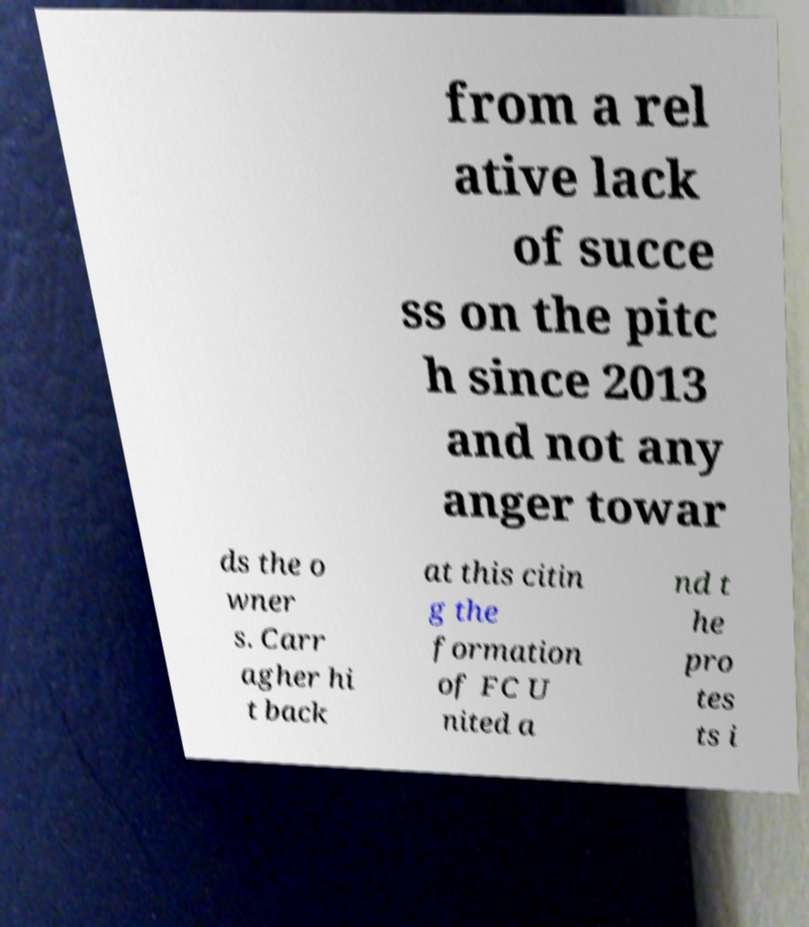What messages or text are displayed in this image? I need them in a readable, typed format. from a rel ative lack of succe ss on the pitc h since 2013 and not any anger towar ds the o wner s. Carr agher hi t back at this citin g the formation of FC U nited a nd t he pro tes ts i 